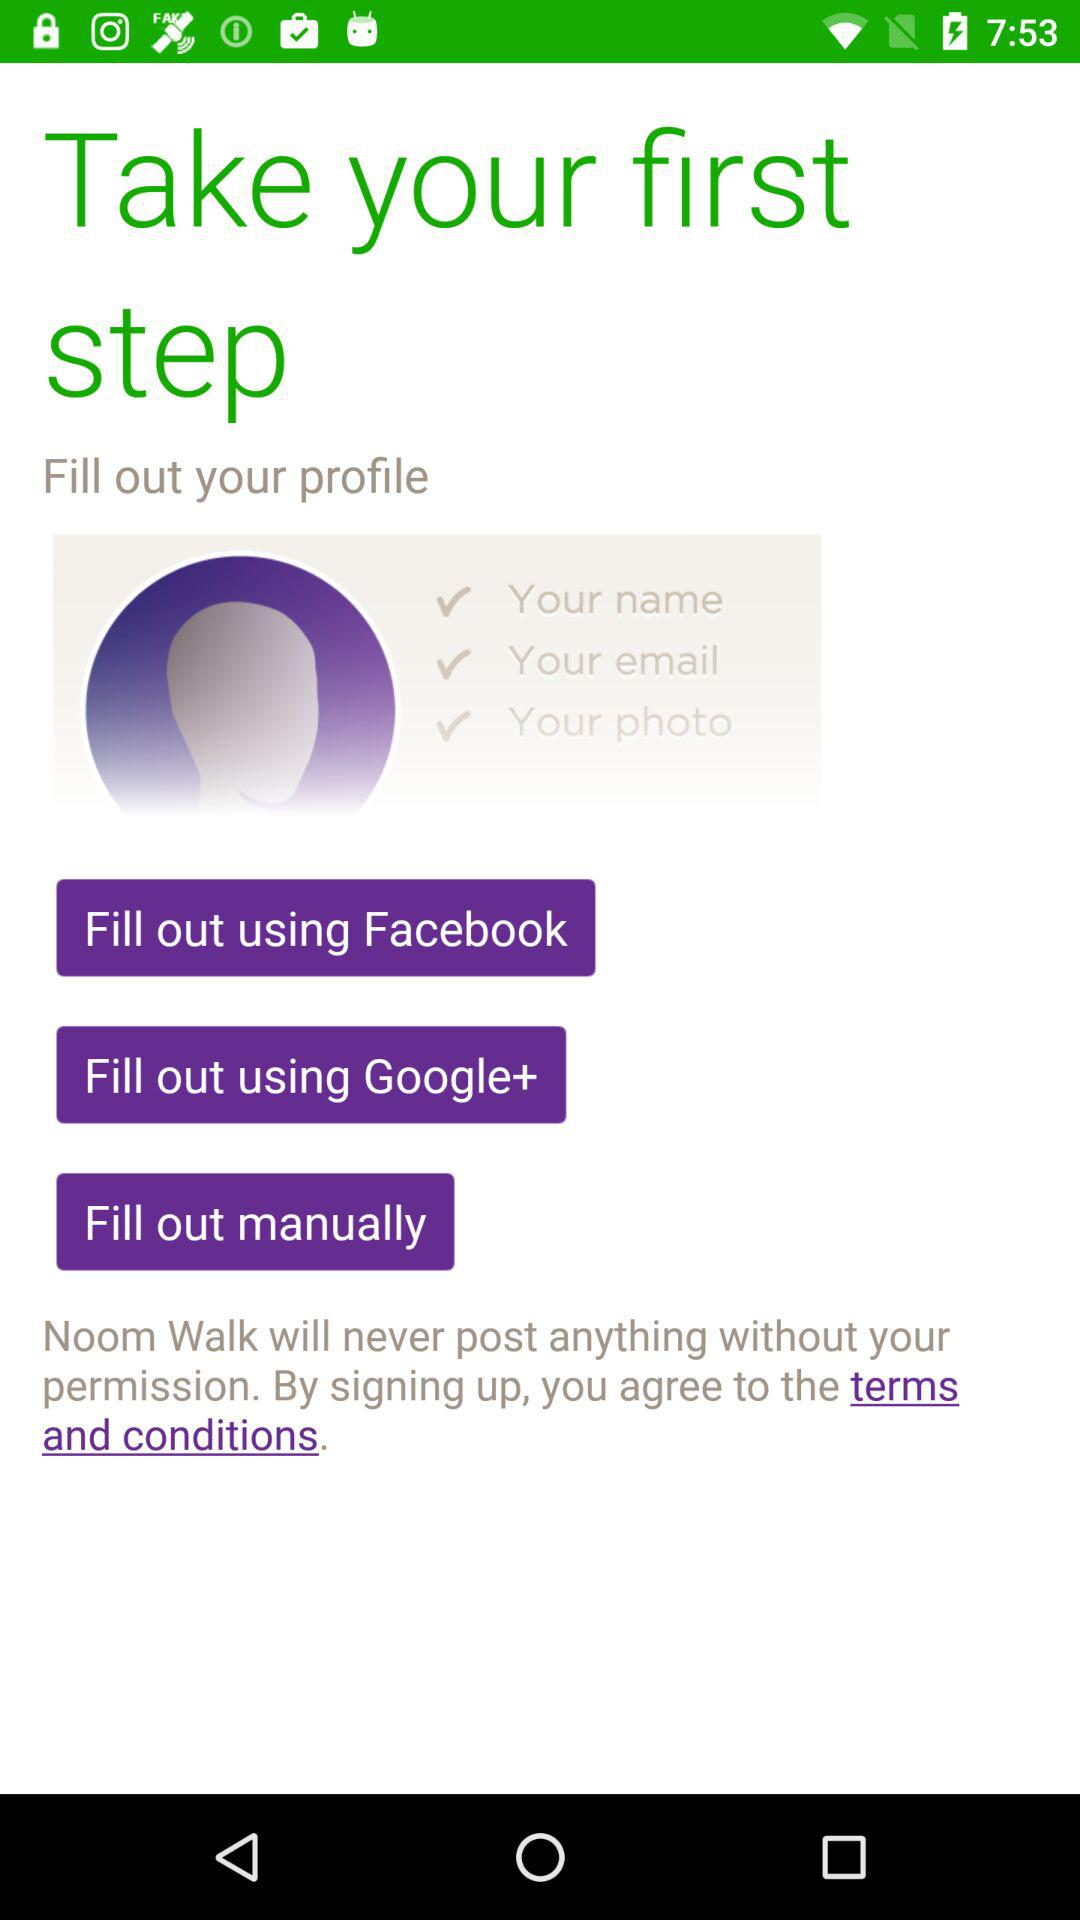How many options are available for signing up?
Answer the question using a single word or phrase. 3 